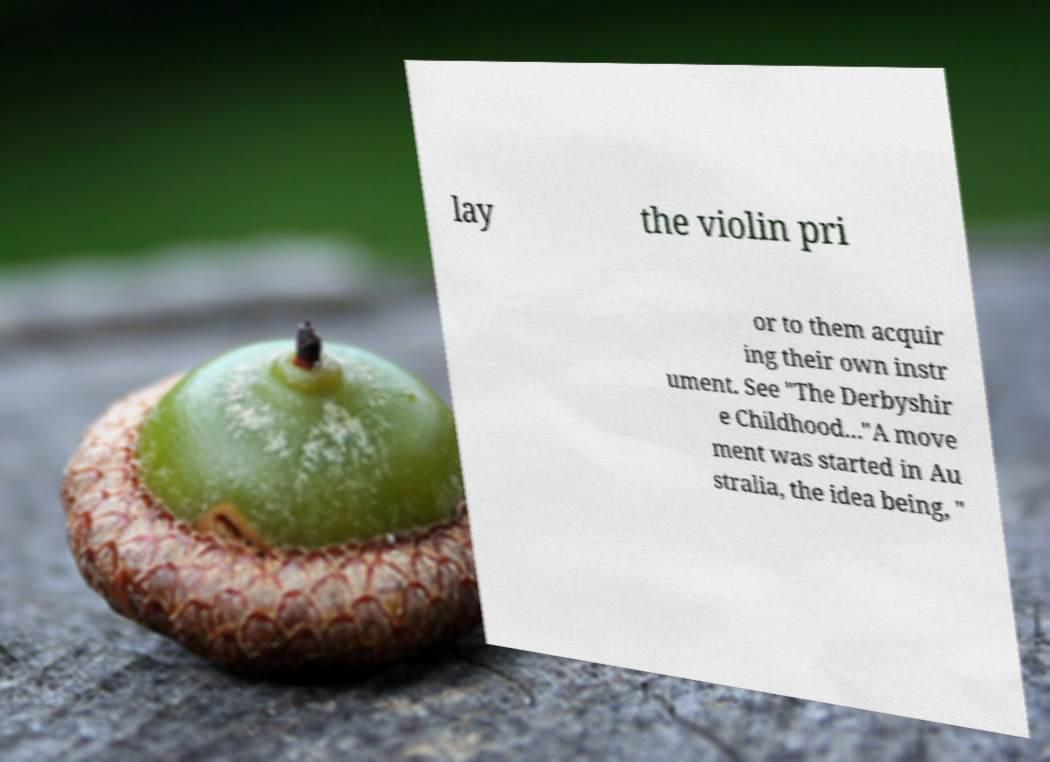Can you read and provide the text displayed in the image?This photo seems to have some interesting text. Can you extract and type it out for me? lay the violin pri or to them acquir ing their own instr ument. See "The Derbyshir e Childhood..."A move ment was started in Au stralia, the idea being, " 